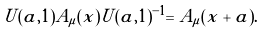<formula> <loc_0><loc_0><loc_500><loc_500>U ( a , 1 ) A _ { \mu } ( x ) U ( a , 1 ) ^ { - 1 } = A _ { \mu } ( x + a ) .</formula> 